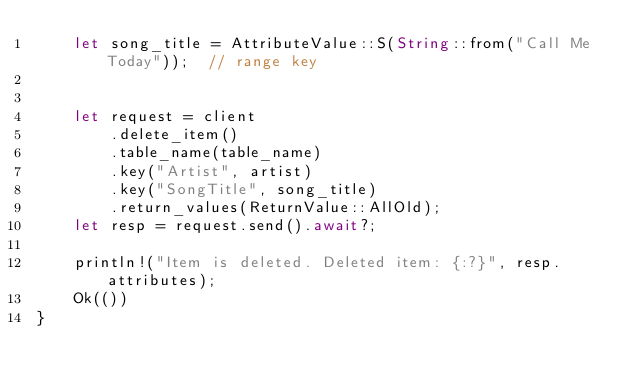Convert code to text. <code><loc_0><loc_0><loc_500><loc_500><_Rust_>    let song_title = AttributeValue::S(String::from("Call Me Today"));  // range key


    let request = client
        .delete_item()
        .table_name(table_name)
        .key("Artist", artist)
        .key("SongTitle", song_title)
        .return_values(ReturnValue::AllOld);
    let resp = request.send().await?;

    println!("Item is deleted. Deleted item: {:?}", resp.attributes);
    Ok(())
}
</code> 